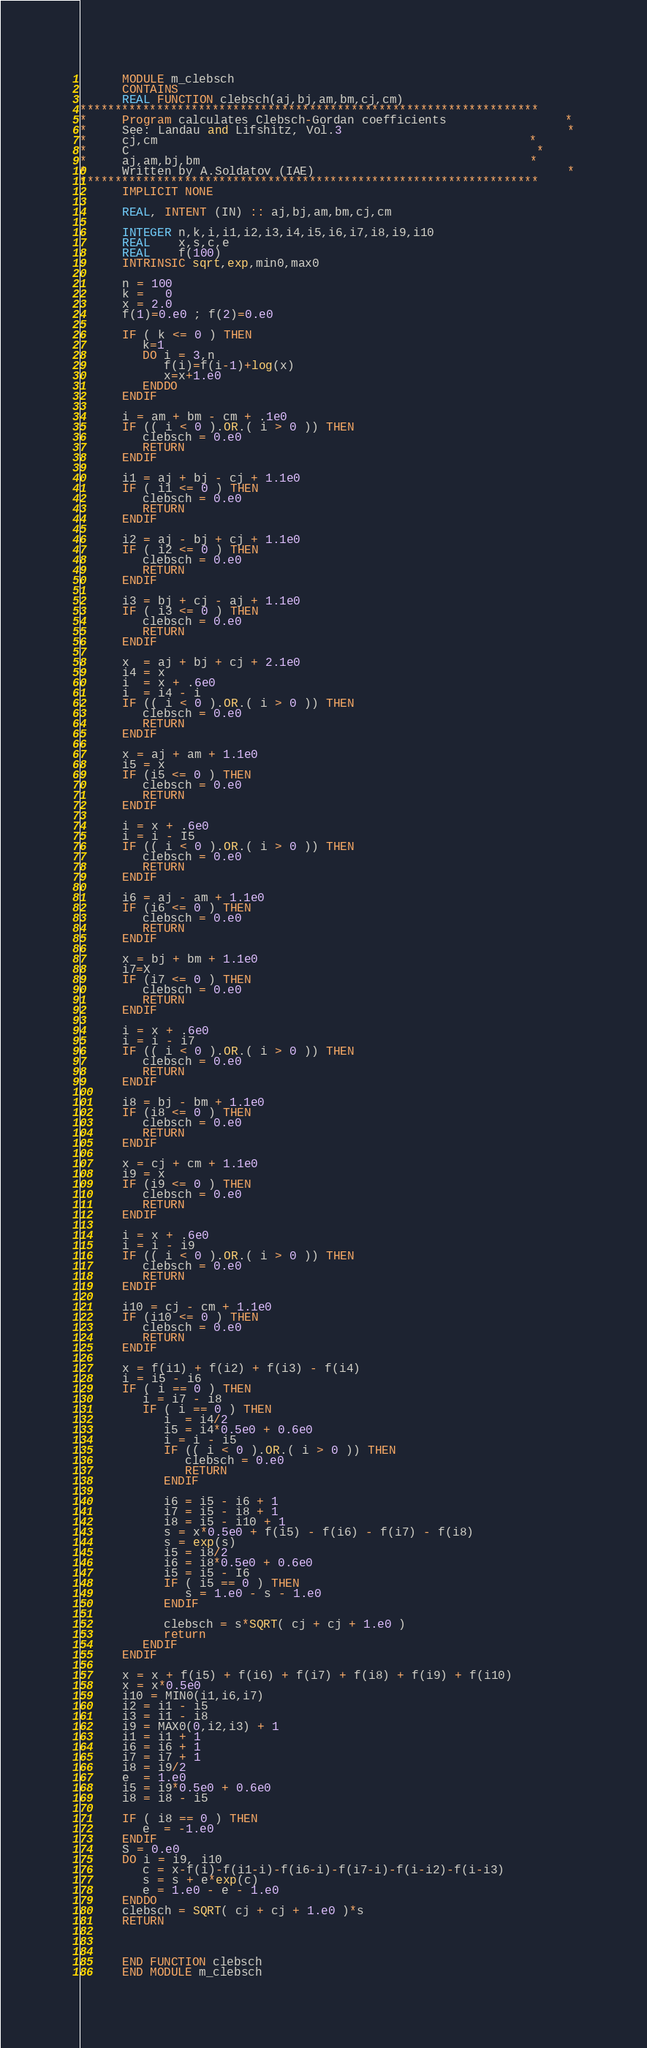Convert code to text. <code><loc_0><loc_0><loc_500><loc_500><_FORTRAN_>      MODULE m_clebsch
      CONTAINS
      REAL FUNCTION clebsch(aj,bj,am,bm,cj,cm)
******************************************************************
*     Program calculates Clebsch-Gordan coefficients                 *
*     See: Landau and Lifshitz, Vol.3                                *
*     cj,cm                                                     *
*     C                                                          *
*     aj,am,bj,bm                                               *
*     Written by A.Soldatov (IAE)                                    *
******************************************************************
      IMPLICIT NONE

      REAL, INTENT (IN) :: aj,bj,am,bm,cj,cm

      INTEGER n,k,i,i1,i2,i3,i4,i5,i6,i7,i8,i9,i10
      REAL    x,s,c,e
      REAL    f(100)
      INTRINSIC sqrt,exp,min0,max0

      n = 100
      k =   0
      x = 2.0
      f(1)=0.e0 ; f(2)=0.e0

      IF ( k <= 0 ) THEN
         k=1
         DO i = 3,n
            f(i)=f(i-1)+log(x)
            x=x+1.e0
         ENDDO
      ENDIF

      i = am + bm - cm + .1e0
      IF (( i < 0 ).OR.( i > 0 )) THEN
         clebsch = 0.e0
         RETURN
      ENDIF

      i1 = aj + bj - cj + 1.1e0
      IF ( i1 <= 0 ) THEN
         clebsch = 0.e0
         RETURN
      ENDIF

      i2 = aj - bj + cj + 1.1e0
      IF ( i2 <= 0 ) THEN
         clebsch = 0.e0
         RETURN
      ENDIF

      i3 = bj + cj - aj + 1.1e0
      IF ( i3 <= 0 ) THEN
         clebsch = 0.e0
         RETURN
      ENDIF

      x  = aj + bj + cj + 2.1e0
      i4 = x
      i  = x + .6e0
      i  = i4 - i
      IF (( i < 0 ).OR.( i > 0 )) THEN
         clebsch = 0.e0
         RETURN
      ENDIF

      x = aj + am + 1.1e0
      i5 = x
      IF (i5 <= 0 ) THEN
         clebsch = 0.e0
         RETURN
      ENDIF

      i = x + .6e0
      i = i - I5
      IF (( i < 0 ).OR.( i > 0 )) THEN
         clebsch = 0.e0
         RETURN
      ENDIF

      i6 = aj - am + 1.1e0
      IF (i6 <= 0 ) THEN
         clebsch = 0.e0
         RETURN
      ENDIF

      x = bj + bm + 1.1e0
      i7=X
      IF (i7 <= 0 ) THEN
         clebsch = 0.e0
         RETURN
      ENDIF

      i = x + .6e0
      i = i - i7
      IF (( i < 0 ).OR.( i > 0 )) THEN
         clebsch = 0.e0
         RETURN
      ENDIF

      i8 = bj - bm + 1.1e0
      IF (i8 <= 0 ) THEN
         clebsch = 0.e0
         RETURN
      ENDIF

      x = cj + cm + 1.1e0
      i9 = x
      IF (i9 <= 0 ) THEN
         clebsch = 0.e0
         RETURN
      ENDIF

      i = x + .6e0
      i = i - i9
      IF (( i < 0 ).OR.( i > 0 )) THEN
         clebsch = 0.e0
         RETURN
      ENDIF

      i10 = cj - cm + 1.1e0
      IF (i10 <= 0 ) THEN
         clebsch = 0.e0
         RETURN
      ENDIF

      x = f(i1) + f(i2) + f(i3) - f(i4)
      i = i5 - i6
      IF ( i == 0 ) THEN
         i = i7 - i8
         IF ( i == 0 ) THEN
            i  = i4/2
            i5 = i4*0.5e0 + 0.6e0
            i = i - i5
            IF (( i < 0 ).OR.( i > 0 )) THEN
               clebsch = 0.e0
               RETURN
            ENDIF

            i6 = i5 - i6 + 1
            i7 = i5 - i8 + 1
            i8 = i5 - i10 + 1
            s = x*0.5e0 + f(i5) - f(i6) - f(i7) - f(i8)
            s = exp(s)
            i5 = i8/2
            i6 = i8*0.5e0 + 0.6e0
            i5 = i5 - I6
            IF ( i5 == 0 ) THEN
               s = 1.e0 - s - 1.e0
            ENDIF
            
            clebsch = s*SQRT( cj + cj + 1.e0 )
            return
         ENDIF
      ENDIF
      
      x = x + f(i5) + f(i6) + f(i7) + f(i8) + f(i9) + f(i10)
      x = x*0.5e0
      i10 = MIN0(i1,i6,i7)
      i2 = i1 - i5
      i3 = i1 - i8
      i9 = MAX0(0,i2,i3) + 1
      i1 = i1 + 1
      i6 = i6 + 1
      i7 = i7 + 1
      i8 = i9/2
      e  = 1.e0
      i5 = i9*0.5e0 + 0.6e0
      i8 = i8 - i5

      IF ( i8 == 0 ) THEN
         e  = -1.e0
      ENDIF
      S = 0.e0
      DO i = i9, i10
         c = x-f(i)-f(i1-i)-f(i6-i)-f(i7-i)-f(i-i2)-f(i-i3)
         s = s + e*exp(c)
         e = 1.e0 - e - 1.e0
      ENDDO
      clebsch = SQRT( cj + cj + 1.e0 )*s
      RETURN

      

      END FUNCTION clebsch
      END MODULE m_clebsch
</code> 